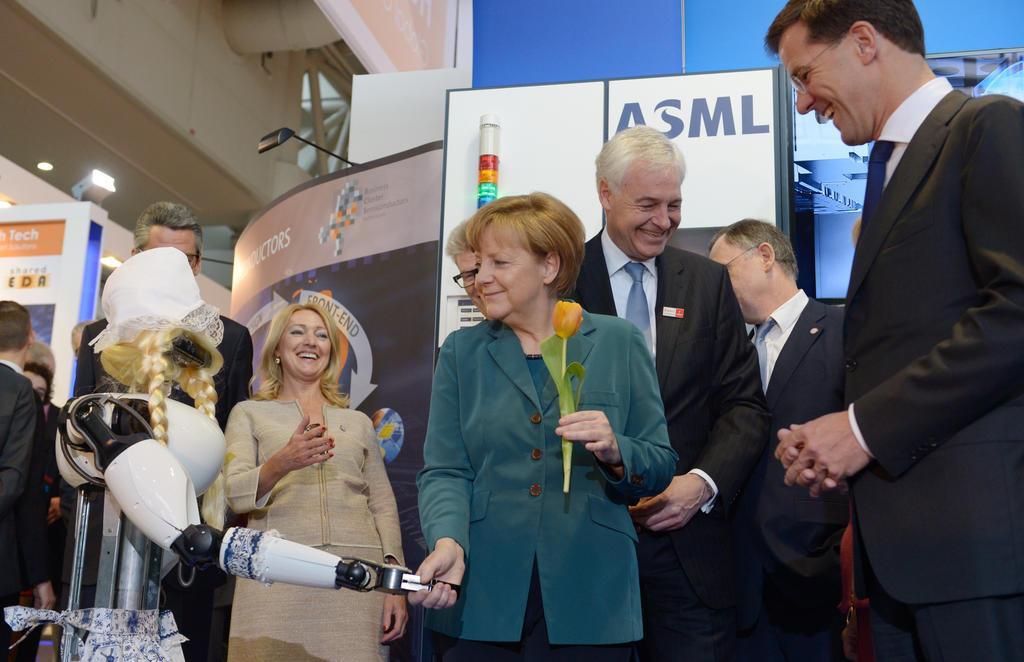In one or two sentences, can you explain what this image depicts? In this image we can see a group of persons and among them we can see a person holding a flower. On the left side, we can see a metal object looks like a robot. Behind the persons we can see boards and banner with text. In the top left, we can see the roof. 